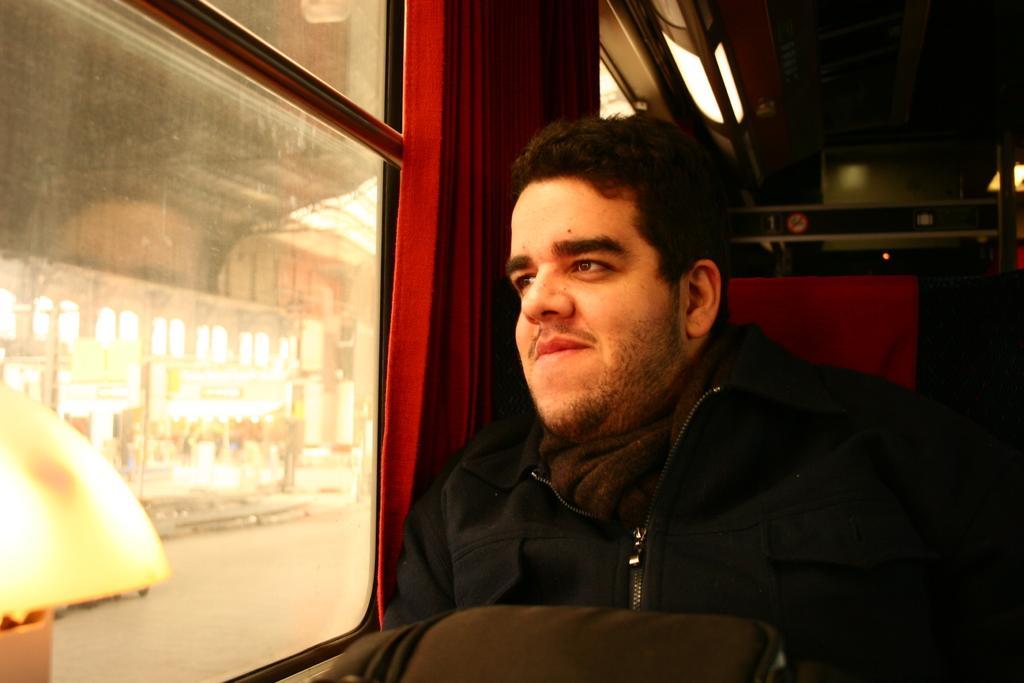In one or two sentences, can you explain what this image depicts? In this image on the foreground we can see there is a person sitting and looking at someone , and on the left side we can see the window. 